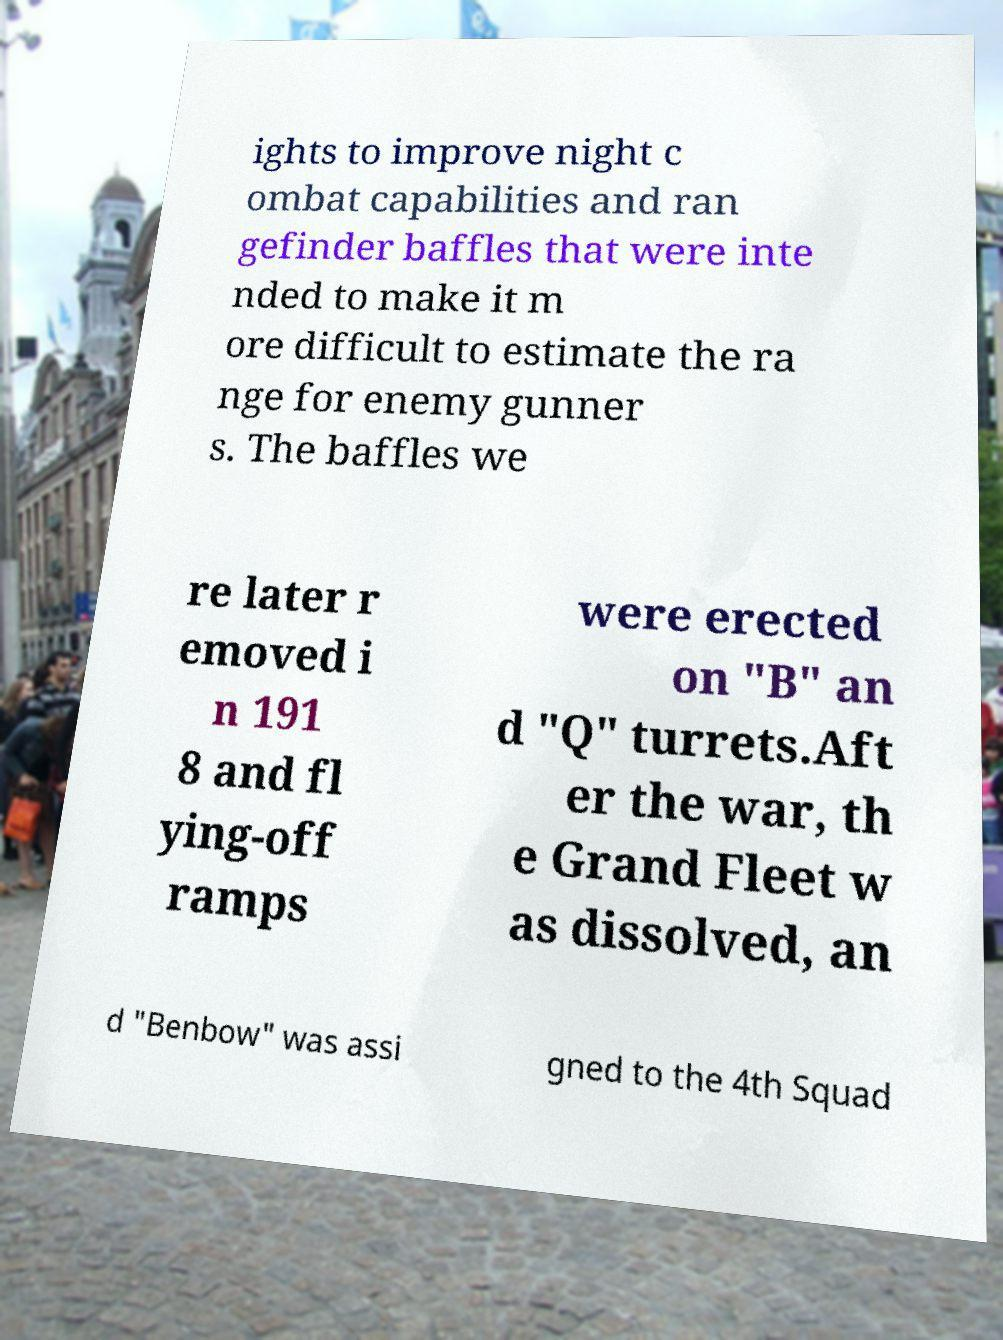There's text embedded in this image that I need extracted. Can you transcribe it verbatim? ights to improve night c ombat capabilities and ran gefinder baffles that were inte nded to make it m ore difficult to estimate the ra nge for enemy gunner s. The baffles we re later r emoved i n 191 8 and fl ying-off ramps were erected on "B" an d "Q" turrets.Aft er the war, th e Grand Fleet w as dissolved, an d "Benbow" was assi gned to the 4th Squad 